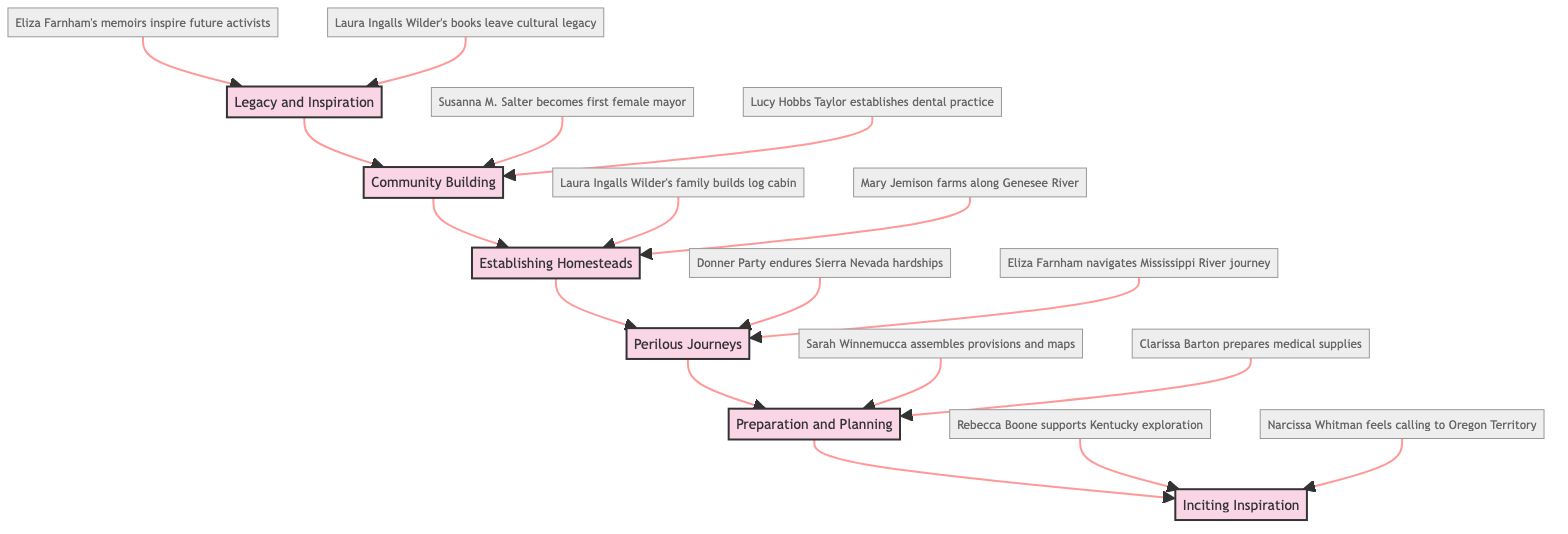What is the top stage in the flowchart? The diagram follows a clear structure with arrows pointing upwards. The stage at the top, which has no other stage above it, is "Legacy and Inspiration".
Answer: Legacy and Inspiration How many stages are represented in the flowchart? By counting each stage from "Inciting Inspiration" to "Legacy and Inspiration", there are six distinct stages listed in the diagram.
Answer: 6 What is one example associated with the "Community Building" stage? Looking at the connections in the flowchart, one specific example provided for the "Community Building" stage is "Susanna M. Salter becomes first female mayor".
Answer: Susanna M. Salter becomes first female mayor Which stage comes after "Preparation and Planning"? The flowchart is structured in a sequential manner, and the stage immediately following "Preparation and Planning" is "Perilous Journeys".
Answer: Perilous Journeys Which example corresponds to the "Establishing Homesteads" stage? Within the diagram's details, an example listed under the "Establishing Homesteads" stage is "Laura Ingalls Wilder's family builds log cabin".
Answer: Laura Ingalls Wilder's family builds log cabin What is the relationship between "Perilous Journeys" and "Community Building"? The diagram shows a direct flow from "Perilous Journeys" to "Establishing Homesteads", followed by a connection to "Community Building", indicating that these stages are sequentially related in the pioneering women's journey.
Answer: Sequential How does "Inciting Inspiration" relate to "Legacy and Inspiration"? The diagram indicates that "Inciting Inspiration" is the starting point and leads up through various stages, ultimately connecting to "Legacy and Inspiration" as the final stage, showcasing the growth and progression in pioneering efforts.
Answer: Growth and progression What type of journey is described in the "Perilous Journeys" stage? The description under this stage highlights the journey as "long and arduous", focusing on the challenging aspects that women faced during their travels.
Answer: Long and arduous 